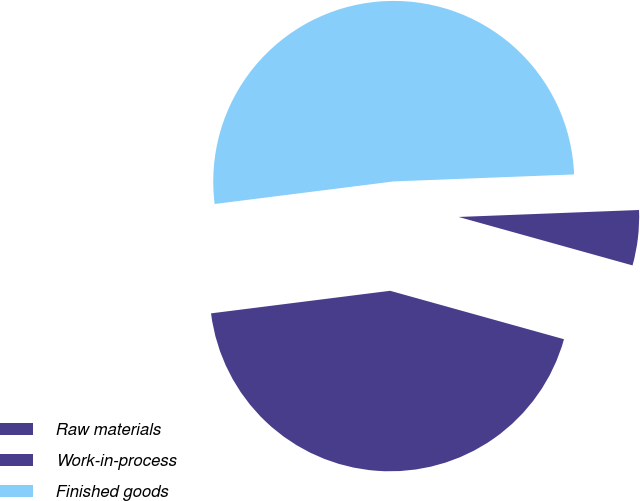<chart> <loc_0><loc_0><loc_500><loc_500><pie_chart><fcel>Raw materials<fcel>Work-in-process<fcel>Finished goods<nl><fcel>43.68%<fcel>4.94%<fcel>51.38%<nl></chart> 